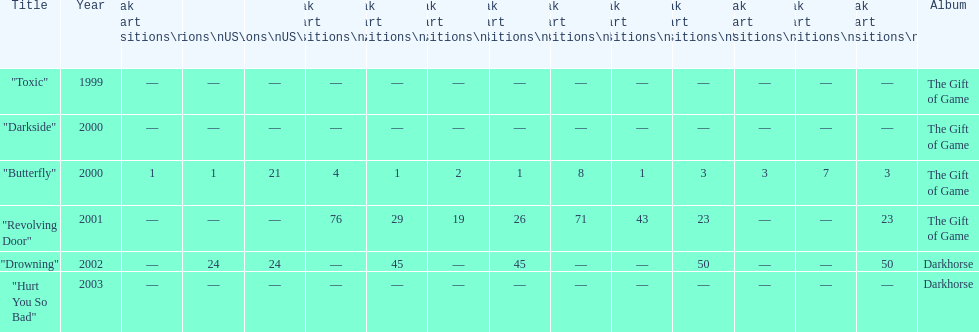How many times did the single "butterfly" rank as 1 in the chart? 5. 